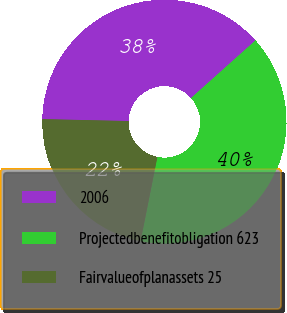<chart> <loc_0><loc_0><loc_500><loc_500><pie_chart><fcel>2006<fcel>Projectedbenefitobligation 623<fcel>Fairvalueofplanassets 25<nl><fcel>38.03%<fcel>39.74%<fcel>22.22%<nl></chart> 